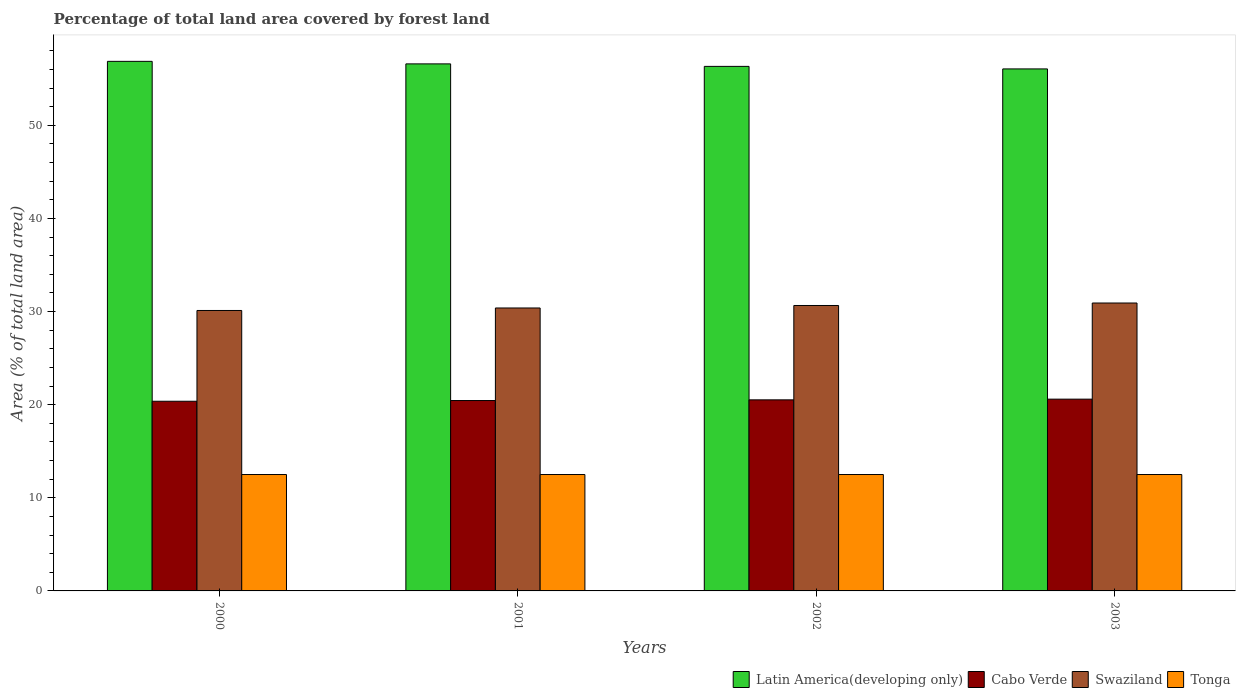How many different coloured bars are there?
Your answer should be compact. 4. How many groups of bars are there?
Keep it short and to the point. 4. Are the number of bars per tick equal to the number of legend labels?
Ensure brevity in your answer.  Yes. How many bars are there on the 1st tick from the left?
Provide a short and direct response. 4. In how many cases, is the number of bars for a given year not equal to the number of legend labels?
Your answer should be compact. 0. What is the percentage of forest land in Cabo Verde in 2000?
Offer a very short reply. 20.37. Across all years, what is the maximum percentage of forest land in Swaziland?
Your answer should be very brief. 30.92. Across all years, what is the minimum percentage of forest land in Latin America(developing only)?
Give a very brief answer. 56.06. In which year was the percentage of forest land in Cabo Verde minimum?
Your response must be concise. 2000. What is the total percentage of forest land in Tonga in the graph?
Your answer should be compact. 50. What is the difference between the percentage of forest land in Cabo Verde in 2000 and that in 2003?
Keep it short and to the point. -0.22. What is the difference between the percentage of forest land in Tonga in 2001 and the percentage of forest land in Latin America(developing only) in 2002?
Ensure brevity in your answer.  -43.83. What is the average percentage of forest land in Latin America(developing only) per year?
Provide a succinct answer. 56.46. In the year 2002, what is the difference between the percentage of forest land in Tonga and percentage of forest land in Swaziland?
Provide a short and direct response. -18.15. In how many years, is the percentage of forest land in Swaziland greater than 28 %?
Keep it short and to the point. 4. Is the percentage of forest land in Cabo Verde in 2001 less than that in 2002?
Provide a succinct answer. Yes. Is the difference between the percentage of forest land in Tonga in 2000 and 2003 greater than the difference between the percentage of forest land in Swaziland in 2000 and 2003?
Provide a short and direct response. Yes. What is the difference between the highest and the second highest percentage of forest land in Cabo Verde?
Keep it short and to the point. 0.07. What is the difference between the highest and the lowest percentage of forest land in Cabo Verde?
Make the answer very short. 0.22. In how many years, is the percentage of forest land in Swaziland greater than the average percentage of forest land in Swaziland taken over all years?
Your answer should be compact. 2. Is it the case that in every year, the sum of the percentage of forest land in Latin America(developing only) and percentage of forest land in Tonga is greater than the sum of percentage of forest land in Swaziland and percentage of forest land in Cabo Verde?
Ensure brevity in your answer.  Yes. What does the 2nd bar from the left in 2001 represents?
Your answer should be compact. Cabo Verde. What does the 2nd bar from the right in 2002 represents?
Offer a terse response. Swaziland. Is it the case that in every year, the sum of the percentage of forest land in Swaziland and percentage of forest land in Cabo Verde is greater than the percentage of forest land in Tonga?
Your answer should be very brief. Yes. Are all the bars in the graph horizontal?
Offer a terse response. No. How many years are there in the graph?
Keep it short and to the point. 4. What is the difference between two consecutive major ticks on the Y-axis?
Offer a terse response. 10. How many legend labels are there?
Keep it short and to the point. 4. What is the title of the graph?
Offer a terse response. Percentage of total land area covered by forest land. What is the label or title of the X-axis?
Provide a succinct answer. Years. What is the label or title of the Y-axis?
Your response must be concise. Area (% of total land area). What is the Area (% of total land area) of Latin America(developing only) in 2000?
Offer a very short reply. 56.87. What is the Area (% of total land area) in Cabo Verde in 2000?
Ensure brevity in your answer.  20.37. What is the Area (% of total land area) in Swaziland in 2000?
Offer a terse response. 30.12. What is the Area (% of total land area) of Latin America(developing only) in 2001?
Your response must be concise. 56.6. What is the Area (% of total land area) of Cabo Verde in 2001?
Your answer should be compact. 20.44. What is the Area (% of total land area) in Swaziland in 2001?
Your answer should be compact. 30.38. What is the Area (% of total land area) in Latin America(developing only) in 2002?
Your response must be concise. 56.33. What is the Area (% of total land area) in Cabo Verde in 2002?
Provide a short and direct response. 20.52. What is the Area (% of total land area) in Swaziland in 2002?
Give a very brief answer. 30.65. What is the Area (% of total land area) of Tonga in 2002?
Provide a succinct answer. 12.5. What is the Area (% of total land area) of Latin America(developing only) in 2003?
Your response must be concise. 56.06. What is the Area (% of total land area) in Cabo Verde in 2003?
Make the answer very short. 20.59. What is the Area (% of total land area) of Swaziland in 2003?
Give a very brief answer. 30.92. What is the Area (% of total land area) in Tonga in 2003?
Offer a terse response. 12.5. Across all years, what is the maximum Area (% of total land area) in Latin America(developing only)?
Ensure brevity in your answer.  56.87. Across all years, what is the maximum Area (% of total land area) of Cabo Verde?
Give a very brief answer. 20.59. Across all years, what is the maximum Area (% of total land area) in Swaziland?
Your answer should be compact. 30.92. Across all years, what is the maximum Area (% of total land area) of Tonga?
Offer a very short reply. 12.5. Across all years, what is the minimum Area (% of total land area) in Latin America(developing only)?
Make the answer very short. 56.06. Across all years, what is the minimum Area (% of total land area) of Cabo Verde?
Your answer should be compact. 20.37. Across all years, what is the minimum Area (% of total land area) of Swaziland?
Your response must be concise. 30.12. What is the total Area (% of total land area) of Latin America(developing only) in the graph?
Offer a terse response. 225.85. What is the total Area (% of total land area) of Cabo Verde in the graph?
Give a very brief answer. 81.93. What is the total Area (% of total land area) in Swaziland in the graph?
Your response must be concise. 122.07. What is the difference between the Area (% of total land area) of Latin America(developing only) in 2000 and that in 2001?
Keep it short and to the point. 0.27. What is the difference between the Area (% of total land area) of Cabo Verde in 2000 and that in 2001?
Give a very brief answer. -0.07. What is the difference between the Area (% of total land area) of Swaziland in 2000 and that in 2001?
Your answer should be very brief. -0.27. What is the difference between the Area (% of total land area) in Tonga in 2000 and that in 2001?
Offer a terse response. 0. What is the difference between the Area (% of total land area) in Latin America(developing only) in 2000 and that in 2002?
Give a very brief answer. 0.54. What is the difference between the Area (% of total land area) in Cabo Verde in 2000 and that in 2002?
Offer a very short reply. -0.15. What is the difference between the Area (% of total land area) in Swaziland in 2000 and that in 2002?
Offer a very short reply. -0.53. What is the difference between the Area (% of total land area) of Latin America(developing only) in 2000 and that in 2003?
Your response must be concise. 0.81. What is the difference between the Area (% of total land area) in Cabo Verde in 2000 and that in 2003?
Offer a very short reply. -0.22. What is the difference between the Area (% of total land area) in Swaziland in 2000 and that in 2003?
Keep it short and to the point. -0.8. What is the difference between the Area (% of total land area) of Tonga in 2000 and that in 2003?
Your answer should be very brief. 0. What is the difference between the Area (% of total land area) in Latin America(developing only) in 2001 and that in 2002?
Your answer should be very brief. 0.27. What is the difference between the Area (% of total land area) of Cabo Verde in 2001 and that in 2002?
Your response must be concise. -0.07. What is the difference between the Area (% of total land area) of Swaziland in 2001 and that in 2002?
Provide a short and direct response. -0.27. What is the difference between the Area (% of total land area) of Tonga in 2001 and that in 2002?
Your answer should be compact. 0. What is the difference between the Area (% of total land area) in Latin America(developing only) in 2001 and that in 2003?
Ensure brevity in your answer.  0.54. What is the difference between the Area (% of total land area) in Cabo Verde in 2001 and that in 2003?
Provide a short and direct response. -0.15. What is the difference between the Area (% of total land area) of Swaziland in 2001 and that in 2003?
Your response must be concise. -0.53. What is the difference between the Area (% of total land area) in Tonga in 2001 and that in 2003?
Provide a succinct answer. 0. What is the difference between the Area (% of total land area) in Latin America(developing only) in 2002 and that in 2003?
Keep it short and to the point. 0.27. What is the difference between the Area (% of total land area) in Cabo Verde in 2002 and that in 2003?
Provide a short and direct response. -0.07. What is the difference between the Area (% of total land area) in Swaziland in 2002 and that in 2003?
Your answer should be compact. -0.27. What is the difference between the Area (% of total land area) of Latin America(developing only) in 2000 and the Area (% of total land area) of Cabo Verde in 2001?
Offer a very short reply. 36.42. What is the difference between the Area (% of total land area) of Latin America(developing only) in 2000 and the Area (% of total land area) of Swaziland in 2001?
Ensure brevity in your answer.  26.48. What is the difference between the Area (% of total land area) in Latin America(developing only) in 2000 and the Area (% of total land area) in Tonga in 2001?
Keep it short and to the point. 44.37. What is the difference between the Area (% of total land area) of Cabo Verde in 2000 and the Area (% of total land area) of Swaziland in 2001?
Provide a short and direct response. -10.01. What is the difference between the Area (% of total land area) of Cabo Verde in 2000 and the Area (% of total land area) of Tonga in 2001?
Ensure brevity in your answer.  7.87. What is the difference between the Area (% of total land area) in Swaziland in 2000 and the Area (% of total land area) in Tonga in 2001?
Provide a succinct answer. 17.62. What is the difference between the Area (% of total land area) of Latin America(developing only) in 2000 and the Area (% of total land area) of Cabo Verde in 2002?
Provide a succinct answer. 36.35. What is the difference between the Area (% of total land area) in Latin America(developing only) in 2000 and the Area (% of total land area) in Swaziland in 2002?
Ensure brevity in your answer.  26.22. What is the difference between the Area (% of total land area) of Latin America(developing only) in 2000 and the Area (% of total land area) of Tonga in 2002?
Your response must be concise. 44.37. What is the difference between the Area (% of total land area) in Cabo Verde in 2000 and the Area (% of total land area) in Swaziland in 2002?
Offer a very short reply. -10.28. What is the difference between the Area (% of total land area) in Cabo Verde in 2000 and the Area (% of total land area) in Tonga in 2002?
Your answer should be very brief. 7.87. What is the difference between the Area (% of total land area) in Swaziland in 2000 and the Area (% of total land area) in Tonga in 2002?
Your answer should be compact. 17.62. What is the difference between the Area (% of total land area) of Latin America(developing only) in 2000 and the Area (% of total land area) of Cabo Verde in 2003?
Give a very brief answer. 36.28. What is the difference between the Area (% of total land area) in Latin America(developing only) in 2000 and the Area (% of total land area) in Swaziland in 2003?
Your answer should be compact. 25.95. What is the difference between the Area (% of total land area) in Latin America(developing only) in 2000 and the Area (% of total land area) in Tonga in 2003?
Keep it short and to the point. 44.37. What is the difference between the Area (% of total land area) in Cabo Verde in 2000 and the Area (% of total land area) in Swaziland in 2003?
Your answer should be very brief. -10.55. What is the difference between the Area (% of total land area) in Cabo Verde in 2000 and the Area (% of total land area) in Tonga in 2003?
Ensure brevity in your answer.  7.87. What is the difference between the Area (% of total land area) in Swaziland in 2000 and the Area (% of total land area) in Tonga in 2003?
Offer a terse response. 17.62. What is the difference between the Area (% of total land area) in Latin America(developing only) in 2001 and the Area (% of total land area) in Cabo Verde in 2002?
Give a very brief answer. 36.08. What is the difference between the Area (% of total land area) of Latin America(developing only) in 2001 and the Area (% of total land area) of Swaziland in 2002?
Offer a terse response. 25.95. What is the difference between the Area (% of total land area) in Latin America(developing only) in 2001 and the Area (% of total land area) in Tonga in 2002?
Ensure brevity in your answer.  44.1. What is the difference between the Area (% of total land area) in Cabo Verde in 2001 and the Area (% of total land area) in Swaziland in 2002?
Your response must be concise. -10.21. What is the difference between the Area (% of total land area) in Cabo Verde in 2001 and the Area (% of total land area) in Tonga in 2002?
Provide a short and direct response. 7.94. What is the difference between the Area (% of total land area) in Swaziland in 2001 and the Area (% of total land area) in Tonga in 2002?
Provide a short and direct response. 17.88. What is the difference between the Area (% of total land area) of Latin America(developing only) in 2001 and the Area (% of total land area) of Cabo Verde in 2003?
Your answer should be compact. 36. What is the difference between the Area (% of total land area) of Latin America(developing only) in 2001 and the Area (% of total land area) of Swaziland in 2003?
Offer a terse response. 25.68. What is the difference between the Area (% of total land area) in Latin America(developing only) in 2001 and the Area (% of total land area) in Tonga in 2003?
Ensure brevity in your answer.  44.1. What is the difference between the Area (% of total land area) of Cabo Verde in 2001 and the Area (% of total land area) of Swaziland in 2003?
Your answer should be compact. -10.47. What is the difference between the Area (% of total land area) in Cabo Verde in 2001 and the Area (% of total land area) in Tonga in 2003?
Provide a succinct answer. 7.94. What is the difference between the Area (% of total land area) in Swaziland in 2001 and the Area (% of total land area) in Tonga in 2003?
Provide a short and direct response. 17.88. What is the difference between the Area (% of total land area) of Latin America(developing only) in 2002 and the Area (% of total land area) of Cabo Verde in 2003?
Your response must be concise. 35.74. What is the difference between the Area (% of total land area) of Latin America(developing only) in 2002 and the Area (% of total land area) of Swaziland in 2003?
Ensure brevity in your answer.  25.41. What is the difference between the Area (% of total land area) of Latin America(developing only) in 2002 and the Area (% of total land area) of Tonga in 2003?
Make the answer very short. 43.83. What is the difference between the Area (% of total land area) in Cabo Verde in 2002 and the Area (% of total land area) in Tonga in 2003?
Keep it short and to the point. 8.02. What is the difference between the Area (% of total land area) in Swaziland in 2002 and the Area (% of total land area) in Tonga in 2003?
Provide a succinct answer. 18.15. What is the average Area (% of total land area) in Latin America(developing only) per year?
Offer a terse response. 56.46. What is the average Area (% of total land area) in Cabo Verde per year?
Offer a terse response. 20.48. What is the average Area (% of total land area) of Swaziland per year?
Offer a very short reply. 30.52. In the year 2000, what is the difference between the Area (% of total land area) in Latin America(developing only) and Area (% of total land area) in Cabo Verde?
Keep it short and to the point. 36.5. In the year 2000, what is the difference between the Area (% of total land area) of Latin America(developing only) and Area (% of total land area) of Swaziland?
Your answer should be very brief. 26.75. In the year 2000, what is the difference between the Area (% of total land area) in Latin America(developing only) and Area (% of total land area) in Tonga?
Give a very brief answer. 44.37. In the year 2000, what is the difference between the Area (% of total land area) in Cabo Verde and Area (% of total land area) in Swaziland?
Give a very brief answer. -9.75. In the year 2000, what is the difference between the Area (% of total land area) in Cabo Verde and Area (% of total land area) in Tonga?
Keep it short and to the point. 7.87. In the year 2000, what is the difference between the Area (% of total land area) of Swaziland and Area (% of total land area) of Tonga?
Offer a terse response. 17.62. In the year 2001, what is the difference between the Area (% of total land area) of Latin America(developing only) and Area (% of total land area) of Cabo Verde?
Make the answer very short. 36.15. In the year 2001, what is the difference between the Area (% of total land area) in Latin America(developing only) and Area (% of total land area) in Swaziland?
Ensure brevity in your answer.  26.21. In the year 2001, what is the difference between the Area (% of total land area) in Latin America(developing only) and Area (% of total land area) in Tonga?
Your answer should be very brief. 44.1. In the year 2001, what is the difference between the Area (% of total land area) of Cabo Verde and Area (% of total land area) of Swaziland?
Provide a short and direct response. -9.94. In the year 2001, what is the difference between the Area (% of total land area) of Cabo Verde and Area (% of total land area) of Tonga?
Offer a very short reply. 7.94. In the year 2001, what is the difference between the Area (% of total land area) of Swaziland and Area (% of total land area) of Tonga?
Ensure brevity in your answer.  17.88. In the year 2002, what is the difference between the Area (% of total land area) of Latin America(developing only) and Area (% of total land area) of Cabo Verde?
Your answer should be compact. 35.81. In the year 2002, what is the difference between the Area (% of total land area) of Latin America(developing only) and Area (% of total land area) of Swaziland?
Keep it short and to the point. 25.68. In the year 2002, what is the difference between the Area (% of total land area) in Latin America(developing only) and Area (% of total land area) in Tonga?
Make the answer very short. 43.83. In the year 2002, what is the difference between the Area (% of total land area) in Cabo Verde and Area (% of total land area) in Swaziland?
Ensure brevity in your answer.  -10.13. In the year 2002, what is the difference between the Area (% of total land area) of Cabo Verde and Area (% of total land area) of Tonga?
Your answer should be very brief. 8.02. In the year 2002, what is the difference between the Area (% of total land area) in Swaziland and Area (% of total land area) in Tonga?
Provide a succinct answer. 18.15. In the year 2003, what is the difference between the Area (% of total land area) of Latin America(developing only) and Area (% of total land area) of Cabo Verde?
Keep it short and to the point. 35.46. In the year 2003, what is the difference between the Area (% of total land area) of Latin America(developing only) and Area (% of total land area) of Swaziland?
Ensure brevity in your answer.  25.14. In the year 2003, what is the difference between the Area (% of total land area) in Latin America(developing only) and Area (% of total land area) in Tonga?
Your answer should be very brief. 43.56. In the year 2003, what is the difference between the Area (% of total land area) of Cabo Verde and Area (% of total land area) of Swaziland?
Offer a very short reply. -10.33. In the year 2003, what is the difference between the Area (% of total land area) in Cabo Verde and Area (% of total land area) in Tonga?
Provide a succinct answer. 8.09. In the year 2003, what is the difference between the Area (% of total land area) of Swaziland and Area (% of total land area) of Tonga?
Your answer should be compact. 18.42. What is the ratio of the Area (% of total land area) of Tonga in 2000 to that in 2001?
Keep it short and to the point. 1. What is the ratio of the Area (% of total land area) in Latin America(developing only) in 2000 to that in 2002?
Make the answer very short. 1.01. What is the ratio of the Area (% of total land area) in Swaziland in 2000 to that in 2002?
Keep it short and to the point. 0.98. What is the ratio of the Area (% of total land area) in Latin America(developing only) in 2000 to that in 2003?
Your answer should be compact. 1.01. What is the ratio of the Area (% of total land area) in Swaziland in 2000 to that in 2003?
Your response must be concise. 0.97. What is the ratio of the Area (% of total land area) in Tonga in 2000 to that in 2003?
Offer a terse response. 1. What is the ratio of the Area (% of total land area) in Latin America(developing only) in 2001 to that in 2002?
Provide a succinct answer. 1. What is the ratio of the Area (% of total land area) of Cabo Verde in 2001 to that in 2002?
Provide a succinct answer. 1. What is the ratio of the Area (% of total land area) in Tonga in 2001 to that in 2002?
Keep it short and to the point. 1. What is the ratio of the Area (% of total land area) of Latin America(developing only) in 2001 to that in 2003?
Provide a succinct answer. 1.01. What is the ratio of the Area (% of total land area) of Cabo Verde in 2001 to that in 2003?
Your response must be concise. 0.99. What is the ratio of the Area (% of total land area) in Swaziland in 2001 to that in 2003?
Your response must be concise. 0.98. What is the ratio of the Area (% of total land area) in Tonga in 2001 to that in 2003?
Ensure brevity in your answer.  1. What is the ratio of the Area (% of total land area) in Latin America(developing only) in 2002 to that in 2003?
Ensure brevity in your answer.  1. What is the ratio of the Area (% of total land area) of Cabo Verde in 2002 to that in 2003?
Ensure brevity in your answer.  1. What is the ratio of the Area (% of total land area) in Swaziland in 2002 to that in 2003?
Provide a short and direct response. 0.99. What is the ratio of the Area (% of total land area) of Tonga in 2002 to that in 2003?
Your response must be concise. 1. What is the difference between the highest and the second highest Area (% of total land area) of Latin America(developing only)?
Offer a terse response. 0.27. What is the difference between the highest and the second highest Area (% of total land area) of Cabo Verde?
Offer a very short reply. 0.07. What is the difference between the highest and the second highest Area (% of total land area) in Swaziland?
Provide a succinct answer. 0.27. What is the difference between the highest and the second highest Area (% of total land area) in Tonga?
Your answer should be compact. 0. What is the difference between the highest and the lowest Area (% of total land area) in Latin America(developing only)?
Make the answer very short. 0.81. What is the difference between the highest and the lowest Area (% of total land area) of Cabo Verde?
Give a very brief answer. 0.22. What is the difference between the highest and the lowest Area (% of total land area) in Swaziland?
Give a very brief answer. 0.8. What is the difference between the highest and the lowest Area (% of total land area) of Tonga?
Your response must be concise. 0. 